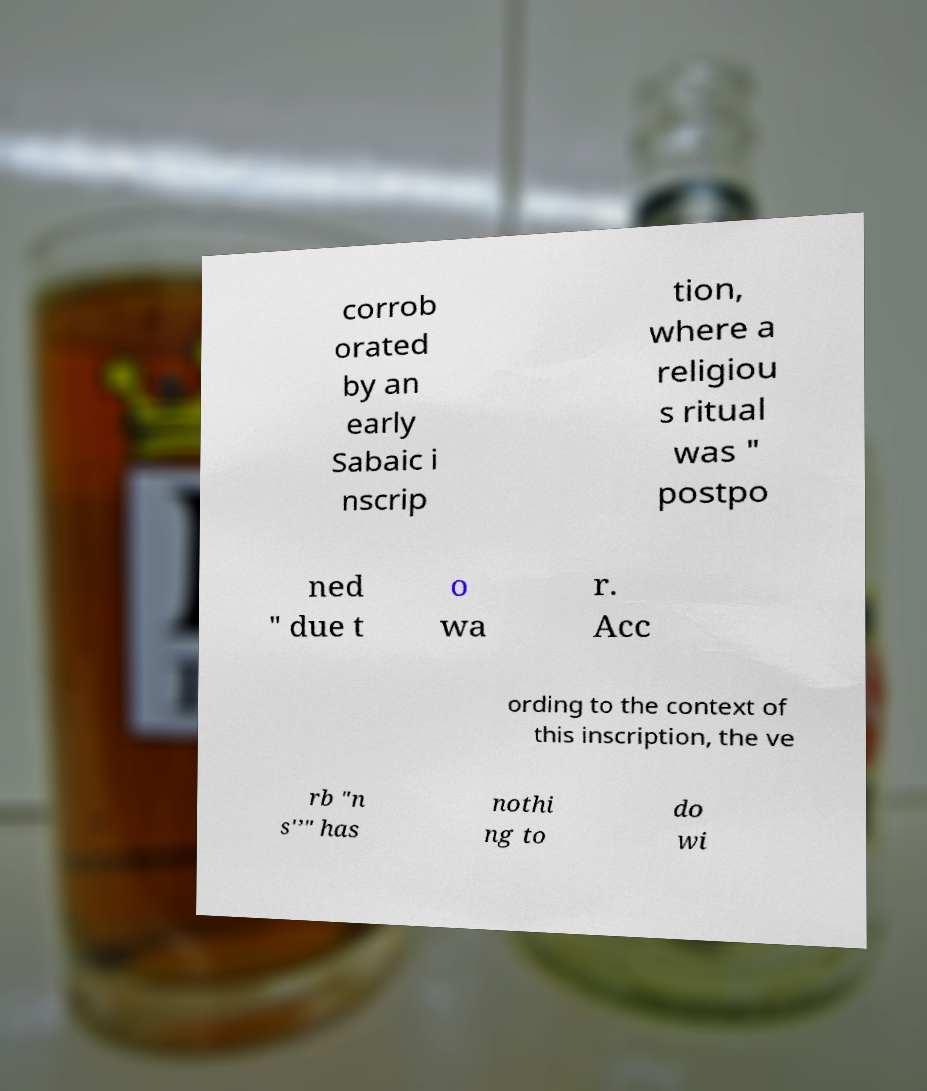Please identify and transcribe the text found in this image. corrob orated by an early Sabaic i nscrip tion, where a religiou s ritual was " postpo ned " due t o wa r. Acc ording to the context of this inscription, the ve rb "n s'’" has nothi ng to do wi 